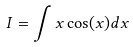Convert formula to latex. <formula><loc_0><loc_0><loc_500><loc_500>I = \int x \cos ( x ) d x</formula> 